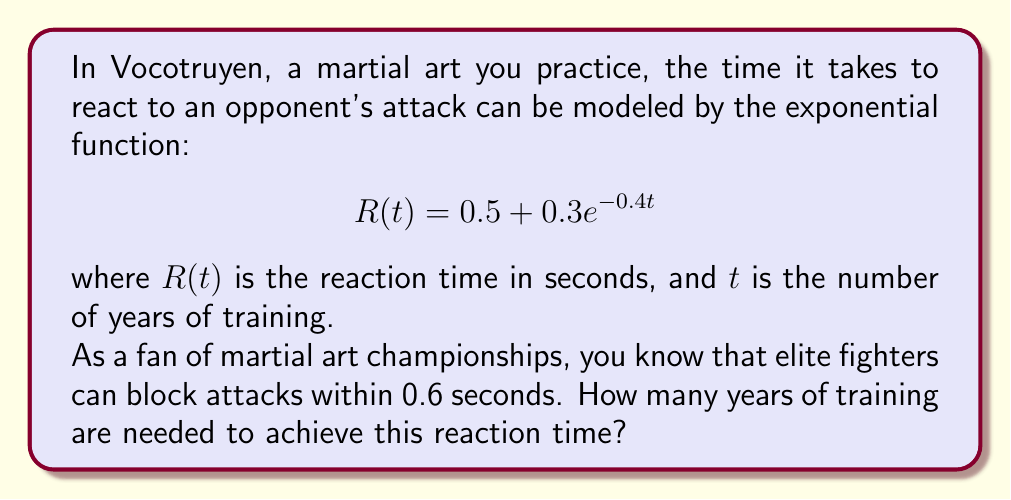Can you answer this question? To solve this problem, we need to use the given exponential function and solve for $t$ when $R(t) = 0.6$ seconds.

1) Set up the equation:
   $$0.6 = 0.5 + 0.3e^{-0.4t}$$

2) Subtract 0.5 from both sides:
   $$0.1 = 0.3e^{-0.4t}$$

3) Divide both sides by 0.3:
   $$\frac{1}{3} = e^{-0.4t}$$

4) Take the natural logarithm of both sides:
   $$\ln(\frac{1}{3}) = \ln(e^{-0.4t})$$

5) Simplify the right side using the properties of logarithms:
   $$\ln(\frac{1}{3}) = -0.4t$$

6) Divide both sides by -0.4:
   $$\frac{\ln(\frac{1}{3})}{-0.4} = t$$

7) Calculate the value:
   $$t \approx 2.75$$

Therefore, approximately 2.75 years of training are needed to achieve a reaction time of 0.6 seconds.
Answer: Approximately 2.75 years of training 